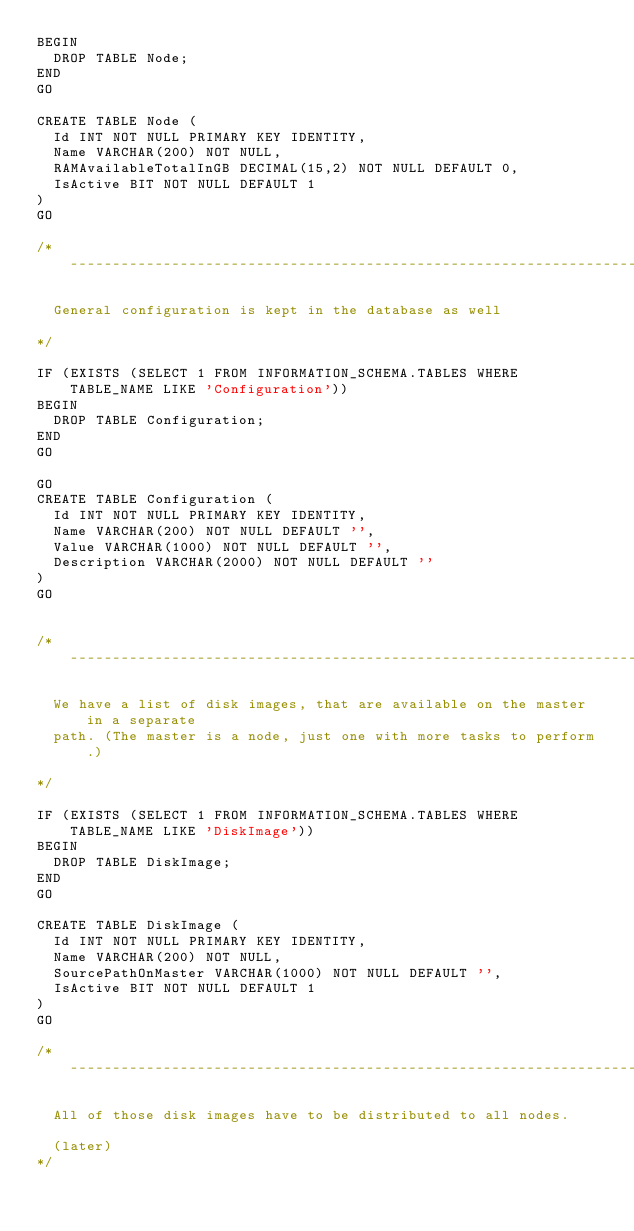Convert code to text. <code><loc_0><loc_0><loc_500><loc_500><_SQL_>BEGIN
	DROP TABLE Node;
END
GO

CREATE TABLE Node (
	Id INT NOT NULL PRIMARY KEY IDENTITY,
	Name VARCHAR(200) NOT NULL,
	RAMAvailableTotalInGB DECIMAL(15,2) NOT NULL DEFAULT 0,
	IsActive BIT NOT NULL DEFAULT 1
)
GO

/* ------------------------------------------------------------------------------------------

	General configuration is kept in the database as well

*/	

IF (EXISTS (SELECT 1 FROM INFORMATION_SCHEMA.TABLES WHERE TABLE_NAME LIKE 'Configuration'))
BEGIN
	DROP TABLE Configuration;
END
GO

GO
CREATE TABLE Configuration (
	Id INT NOT NULL PRIMARY KEY IDENTITY, 
	Name VARCHAR(200) NOT NULL DEFAULT '',
	Value VARCHAR(1000) NOT NULL DEFAULT '',
	Description VARCHAR(2000) NOT NULL DEFAULT ''
)
GO


/* ------------------------------------------------------------------------------------------

	We have a list of disk images, that are available on the master in a separate
	path. (The master is a node, just one with more tasks to perform.)

*/	

IF (EXISTS (SELECT 1 FROM INFORMATION_SCHEMA.TABLES WHERE TABLE_NAME LIKE 'DiskImage'))
BEGIN
	DROP TABLE DiskImage;
END
GO

CREATE TABLE DiskImage (
	Id INT NOT NULL PRIMARY KEY IDENTITY,
	Name VARCHAR(200) NOT NULL,
	SourcePathOnMaster VARCHAR(1000) NOT NULL DEFAULT '',
	IsActive BIT NOT NULL DEFAULT 1
)
GO

/* ------------------------------------------------------------------------------------------

	All of those disk images have to be distributed to all nodes.

	(later)
*/	
</code> 